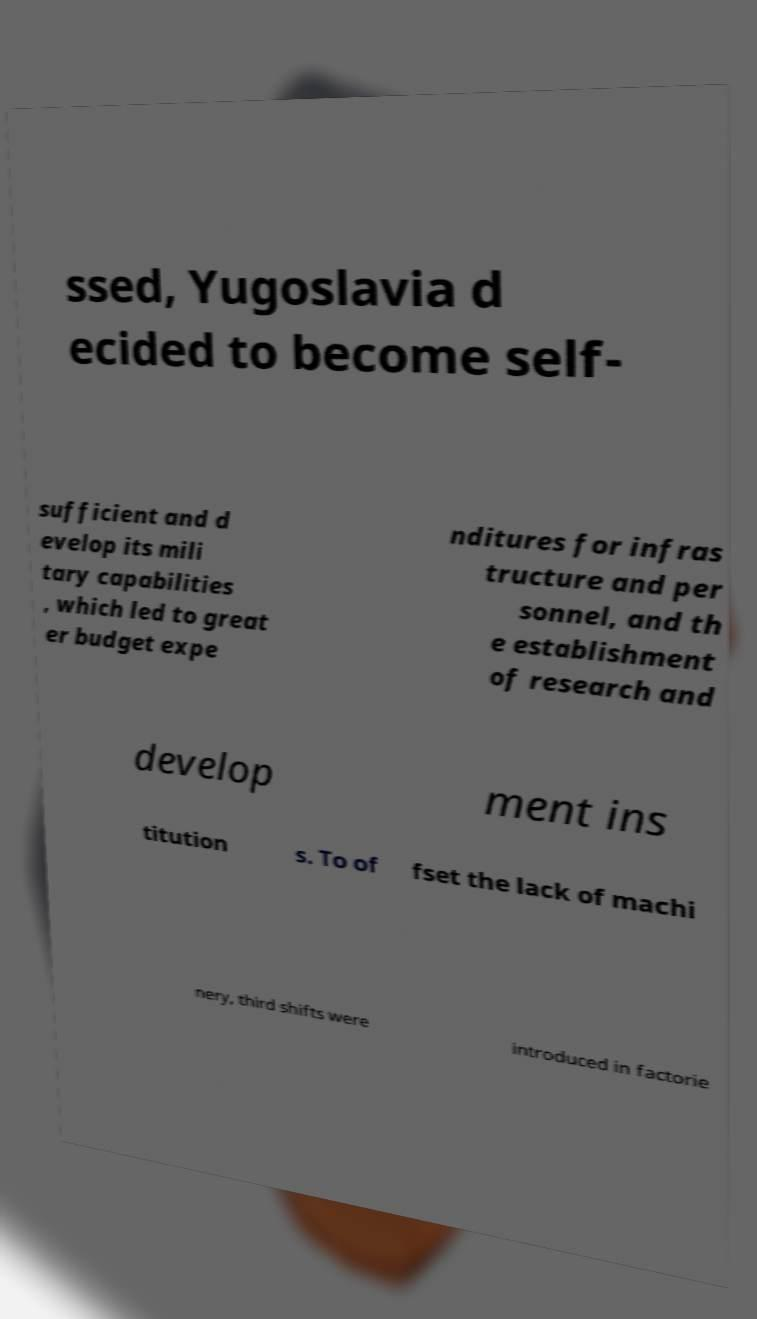For documentation purposes, I need the text within this image transcribed. Could you provide that? ssed, Yugoslavia d ecided to become self- sufficient and d evelop its mili tary capabilities , which led to great er budget expe nditures for infras tructure and per sonnel, and th e establishment of research and develop ment ins titution s. To of fset the lack of machi nery, third shifts were introduced in factorie 